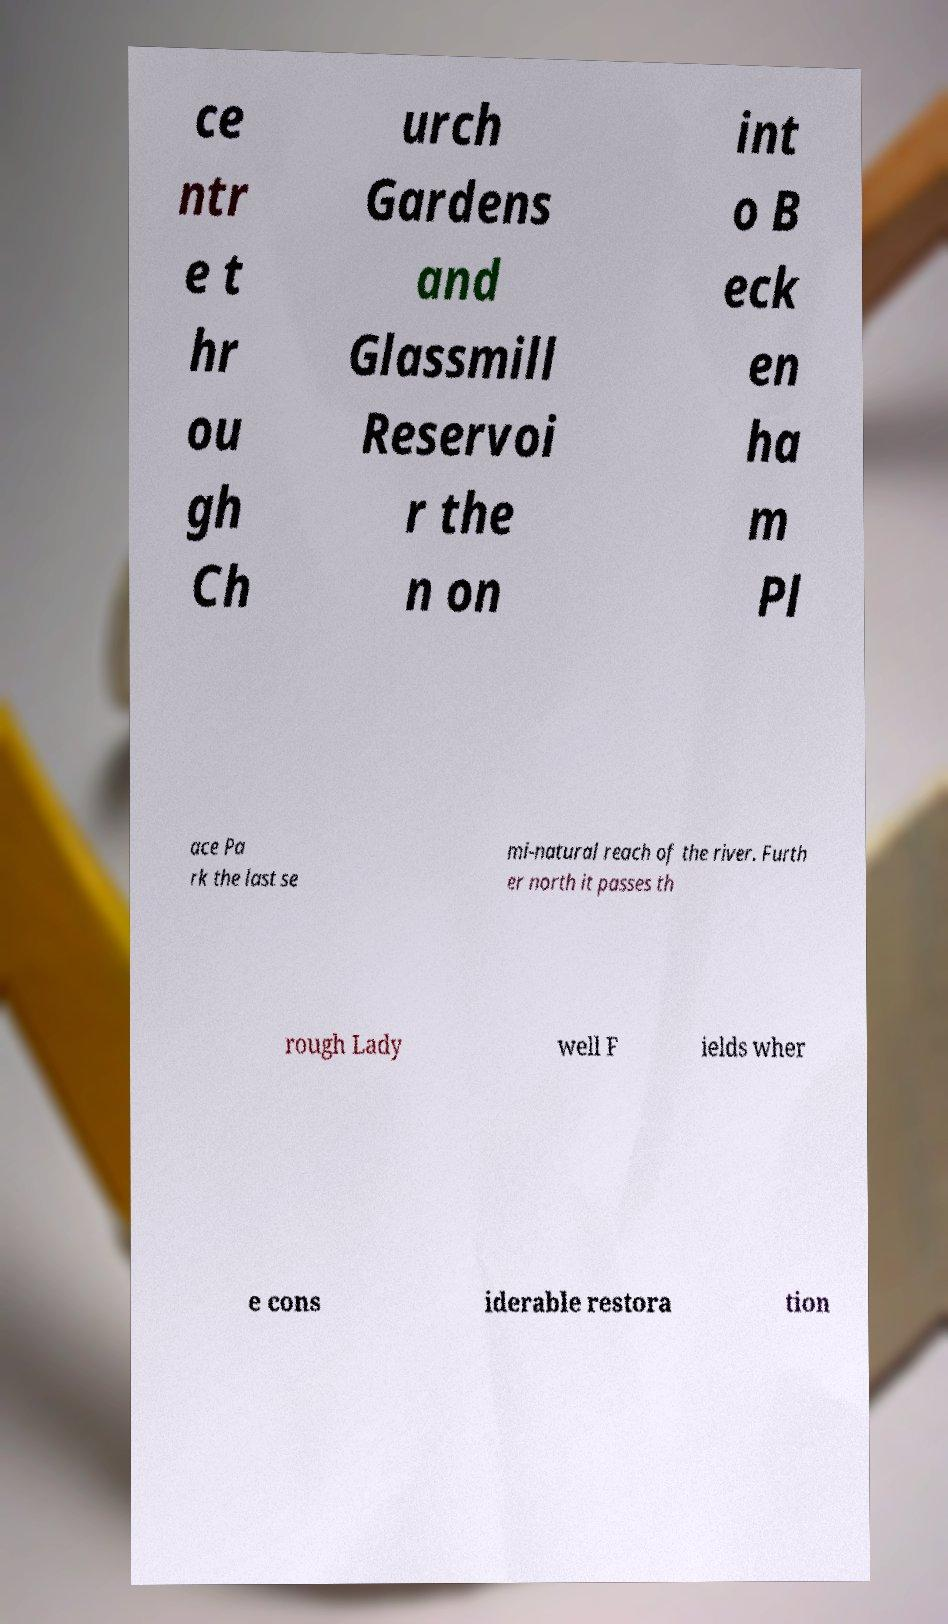Can you accurately transcribe the text from the provided image for me? ce ntr e t hr ou gh Ch urch Gardens and Glassmill Reservoi r the n on int o B eck en ha m Pl ace Pa rk the last se mi-natural reach of the river. Furth er north it passes th rough Lady well F ields wher e cons iderable restora tion 